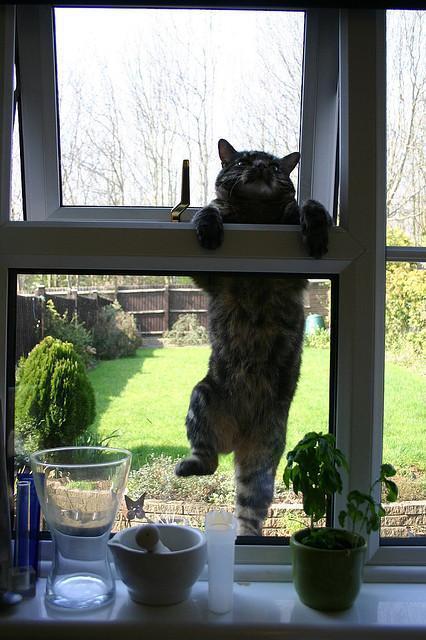What is the cat climbing through?
Make your selection from the four choices given to correctly answer the question.
Options: Cupboard, window, chimney, door. Window. 